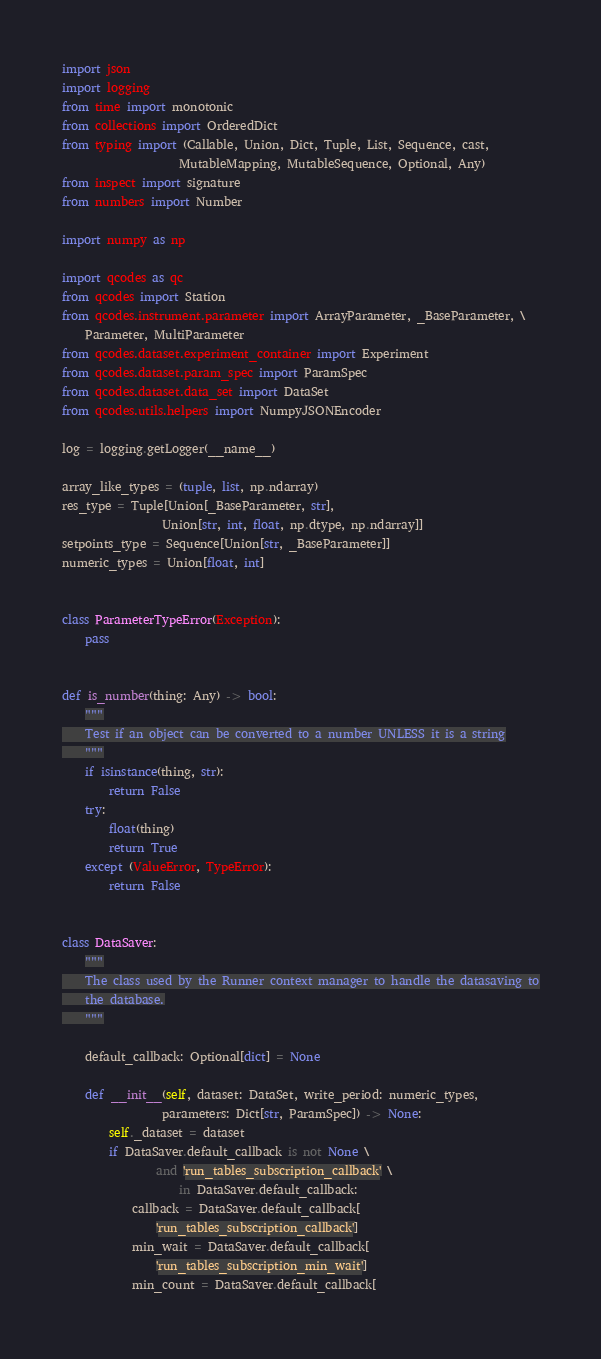<code> <loc_0><loc_0><loc_500><loc_500><_Python_>import json
import logging
from time import monotonic
from collections import OrderedDict
from typing import (Callable, Union, Dict, Tuple, List, Sequence, cast,
                    MutableMapping, MutableSequence, Optional, Any)
from inspect import signature
from numbers import Number

import numpy as np

import qcodes as qc
from qcodes import Station
from qcodes.instrument.parameter import ArrayParameter, _BaseParameter, \
    Parameter, MultiParameter
from qcodes.dataset.experiment_container import Experiment
from qcodes.dataset.param_spec import ParamSpec
from qcodes.dataset.data_set import DataSet
from qcodes.utils.helpers import NumpyJSONEncoder

log = logging.getLogger(__name__)

array_like_types = (tuple, list, np.ndarray)
res_type = Tuple[Union[_BaseParameter, str],
                 Union[str, int, float, np.dtype, np.ndarray]]
setpoints_type = Sequence[Union[str, _BaseParameter]]
numeric_types = Union[float, int]


class ParameterTypeError(Exception):
    pass


def is_number(thing: Any) -> bool:
    """
    Test if an object can be converted to a number UNLESS it is a string
    """
    if isinstance(thing, str):
        return False
    try:
        float(thing)
        return True
    except (ValueError, TypeError):
        return False


class DataSaver:
    """
    The class used by the Runner context manager to handle the datasaving to
    the database.
    """

    default_callback: Optional[dict] = None

    def __init__(self, dataset: DataSet, write_period: numeric_types,
                 parameters: Dict[str, ParamSpec]) -> None:
        self._dataset = dataset
        if DataSaver.default_callback is not None \
                and 'run_tables_subscription_callback' \
                    in DataSaver.default_callback:
            callback = DataSaver.default_callback[
                'run_tables_subscription_callback']
            min_wait = DataSaver.default_callback[
                'run_tables_subscription_min_wait']
            min_count = DataSaver.default_callback[</code> 